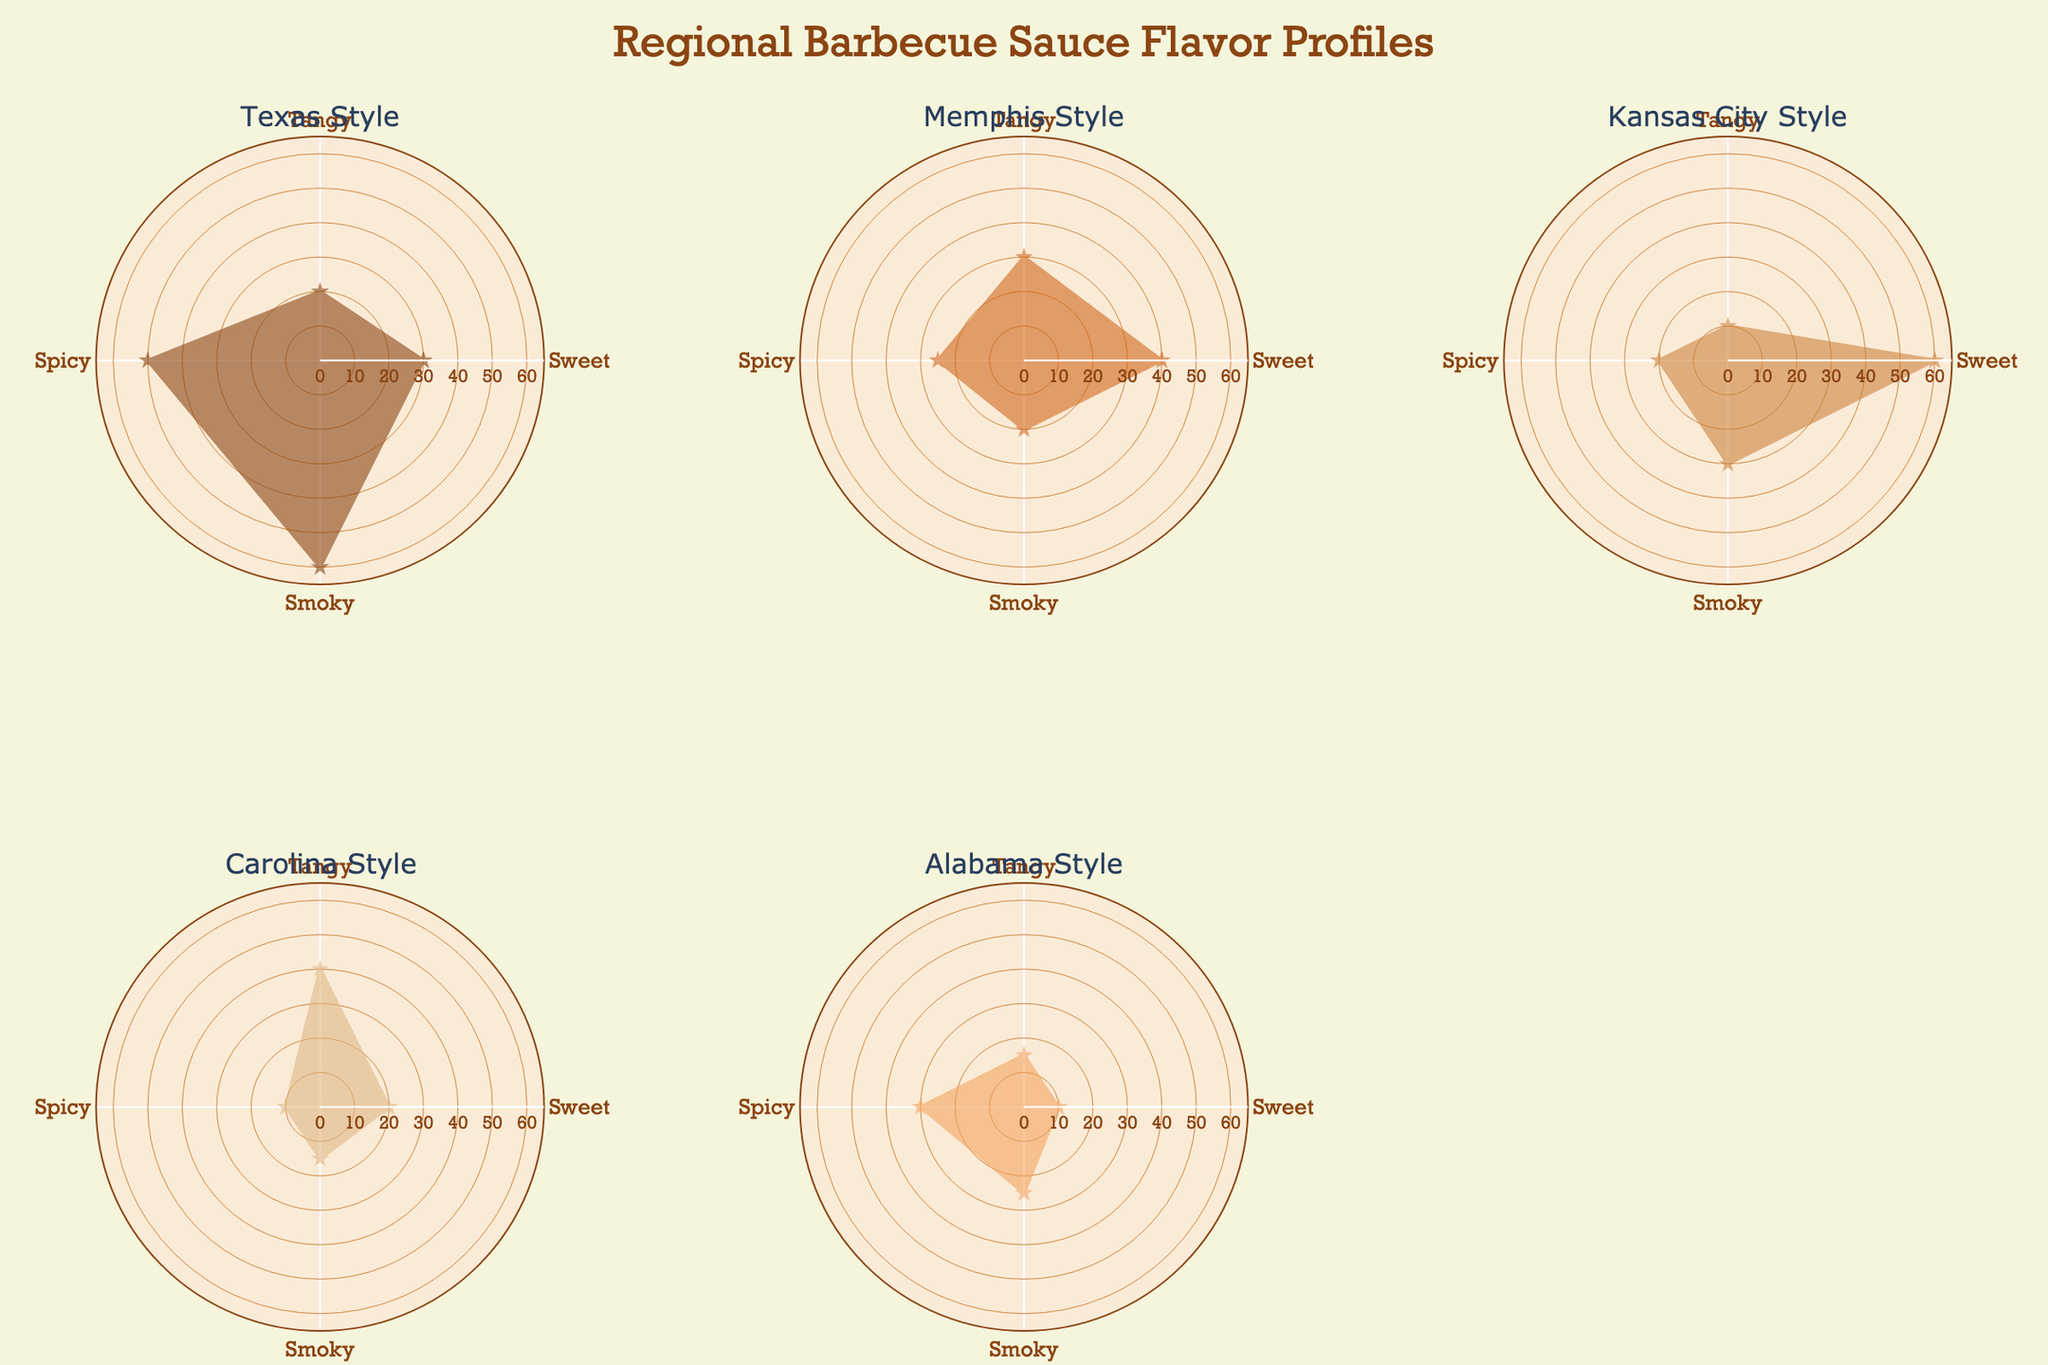what are the five flavors listed in the radar charts? The radar charts represent the distribution of flavor profiles across different barbecue styles. The flavors are listed on the angular axis and include Sweet, Tangy, Spicy, Smoky, and an additional axis cycle back to Sweet.
Answer: Sweet, Tangy, Spicy, Smoky, Sweet What is the dominant flavor in Texas Style barbecue sauce? To find the dominant flavor, look for the highest value on the radar chart for Texas Style. The highest value is at the 'Smoky' flavor, indicated by a high radial distance.
Answer: Smoky Which barbecue style has the most balanced flavor profile? A balanced flavor profile would have similar radial values for all flavors. By visually inspecting the radar charts, Carolina Style shows relatively similar values for each flavor compared to other styles.
Answer: Carolina Style How does the spiciness compare between Texas Style and Kansas City Style? Compare the radial values for the 'Spicy' flavor in both Texas Style and Kansas City Style radar charts. Texas Style has a higher value (50) compared to Kansas City Style (20).
Answer: Texas Style has a higher spiciness Which flavor profile is least prominent in Alabama Style barbecue sauce? Look for the lowest radial value in the Alabama Style radar chart. The lowest value corresponds to the flavor 'Sweet' at 10.
Answer: Sweet What are the differences in the smoky flavor between Memphis Style and Kansas City Style? Compare the radial values for the 'Smoky' flavor in both Memphis Style and Kansas City Style. Memphis Style has a value of 20, whereas Kansas City Style has a value of 30. The difference is 10 units, with Kansas City Style being smokier.
Answer: Kansas City Style is 10 units smokier If you sum up the sweet flavor values across all styles, what is the total? Sum the values for the 'Sweet' flavor across all barbecue styles: 30 (Texas) + 40 (Memphis) + 60 (Kansas City) + 20 (Carolina) + 10 (Alabama) = 160.
Answer: 160 Which style has the highest value for tanginess? Check the radar charts for the 'Tangy' flavor across all styles. Carolina Style has the highest value with 40.
Answer: Carolina Style Between which two barbecue styles is the difference in spiciness most significant? Calculate the differences in spiciness values between all pairs of styles. Texas (50) and Carolina (10) have the most significant difference: 50 - 10 = 40.
Answer: Texas Style and Carolina Style How do the smoky flavors in Texas Style and Alabama Style compare? Look at the radial values for the 'Smoky' flavor in both Texas Style and Alabama Style. Texas Style has 60, and Alabama Style has 25, a significant difference.
Answer: Texas Style is smokier 